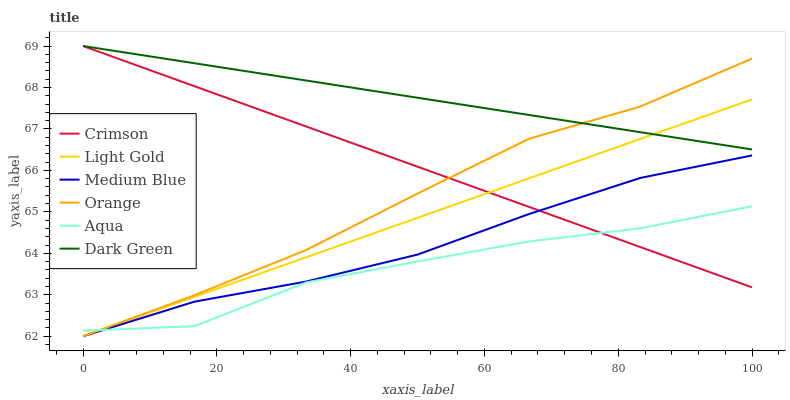Does Aqua have the minimum area under the curve?
Answer yes or no. Yes. Does Dark Green have the maximum area under the curve?
Answer yes or no. Yes. Does Medium Blue have the minimum area under the curve?
Answer yes or no. No. Does Medium Blue have the maximum area under the curve?
Answer yes or no. No. Is Crimson the smoothest?
Answer yes or no. Yes. Is Aqua the roughest?
Answer yes or no. Yes. Is Medium Blue the smoothest?
Answer yes or no. No. Is Medium Blue the roughest?
Answer yes or no. No. Does Crimson have the lowest value?
Answer yes or no. No. Does Medium Blue have the highest value?
Answer yes or no. No. Is Medium Blue less than Dark Green?
Answer yes or no. Yes. Is Dark Green greater than Aqua?
Answer yes or no. Yes. Does Medium Blue intersect Dark Green?
Answer yes or no. No. 